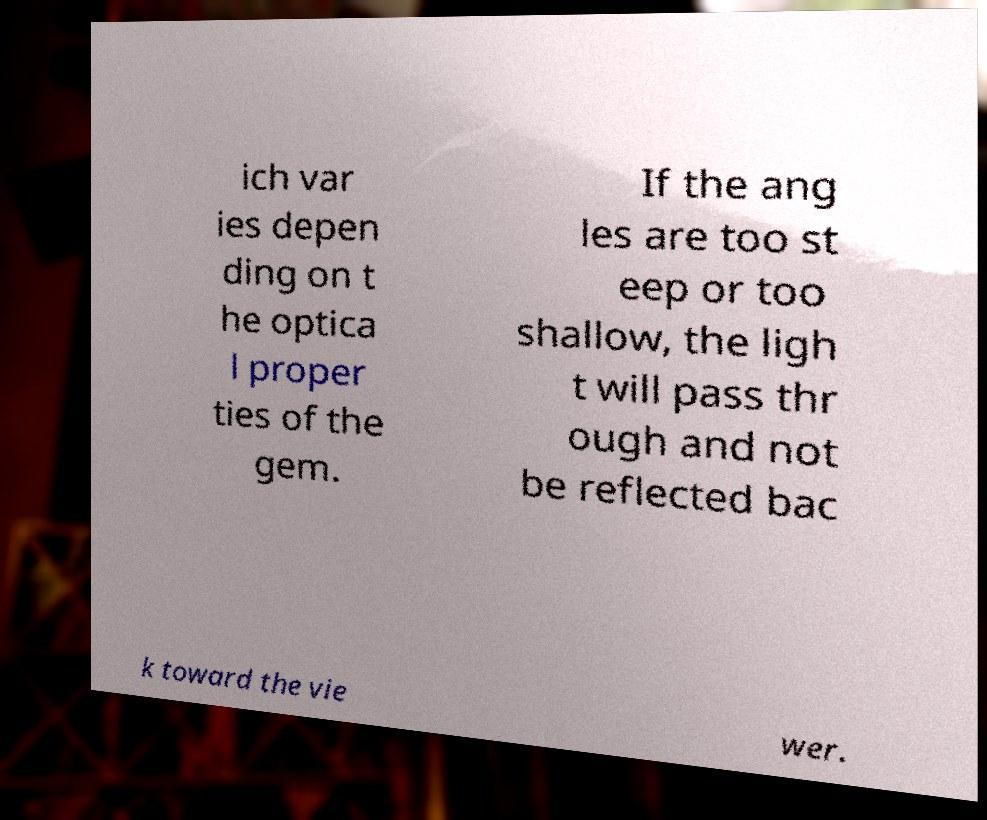Please identify and transcribe the text found in this image. ich var ies depen ding on t he optica l proper ties of the gem. If the ang les are too st eep or too shallow, the ligh t will pass thr ough and not be reflected bac k toward the vie wer. 